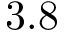Convert formula to latex. <formula><loc_0><loc_0><loc_500><loc_500>3 . 8</formula> 